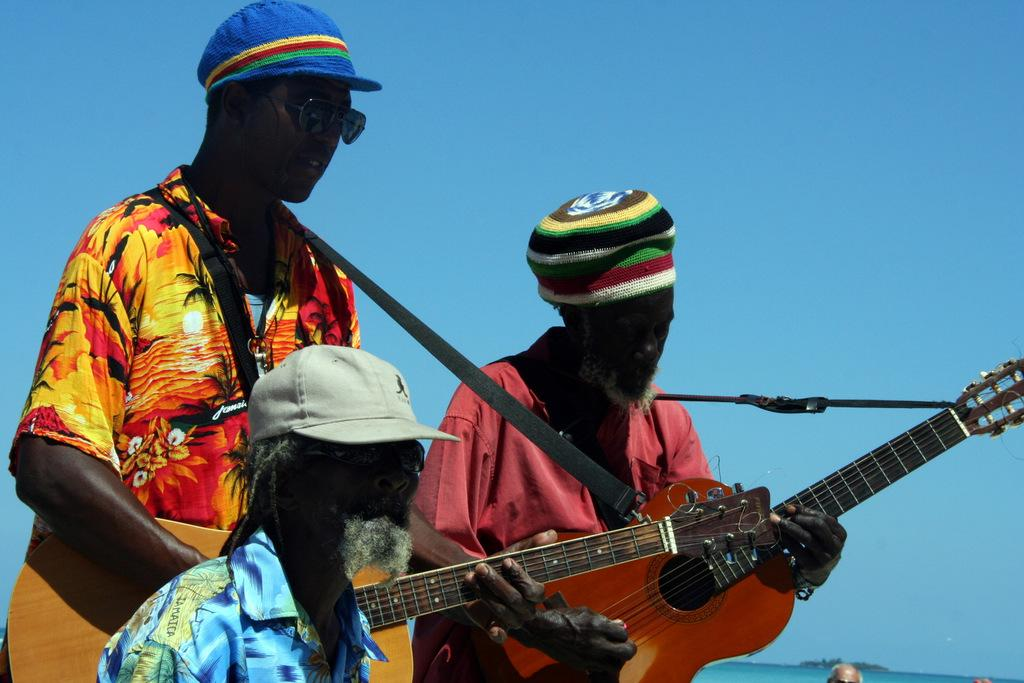How many men are in the image? There are three men in the image. What are the men wearing on their heads? All three men are wearing caps. What are two of the men holding in the image? Two of the men are holding guitars. Can you describe the background of the image? There is a person visible in the background of the image, and the sky is also visible. What type of cup is the goat drinking from in the image? There is no goat or cup present in the image. What type of legal advice is the lawyer providing in the image? There is no lawyer or legal advice present in the image. 